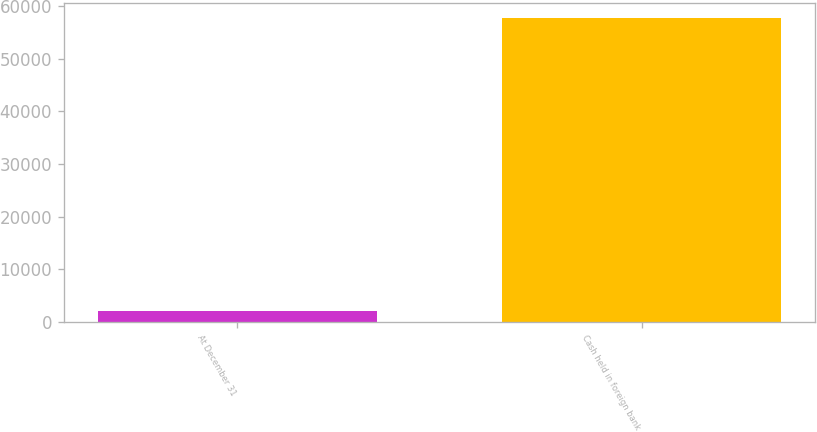Convert chart to OTSL. <chart><loc_0><loc_0><loc_500><loc_500><bar_chart><fcel>At December 31<fcel>Cash held in foreign bank<nl><fcel>2017<fcel>57790<nl></chart> 